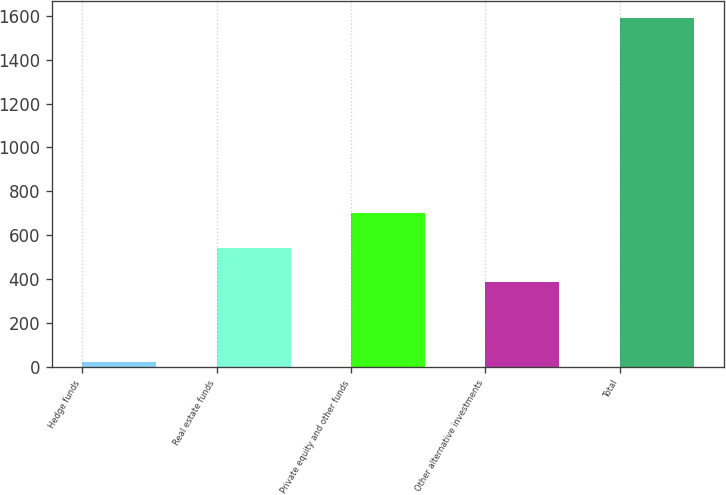<chart> <loc_0><loc_0><loc_500><loc_500><bar_chart><fcel>Hedge funds<fcel>Real estate funds<fcel>Private equity and other funds<fcel>Other alternative investments<fcel>Total<nl><fcel>22<fcel>543.6<fcel>700.2<fcel>387<fcel>1588<nl></chart> 